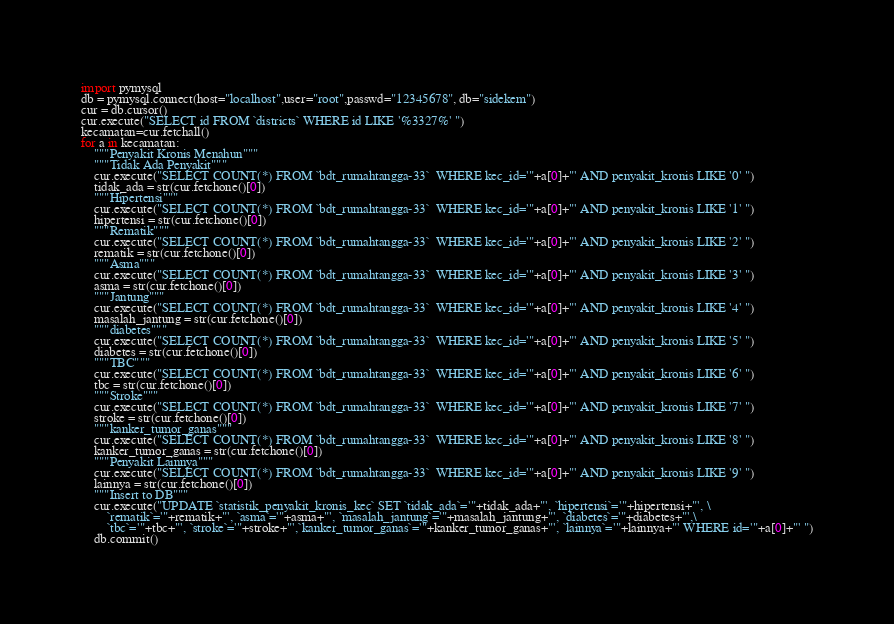<code> <loc_0><loc_0><loc_500><loc_500><_Python_>import pymysql
db = pymysql.connect(host="localhost",user="root",passwd="12345678", db="sidekem")
cur = db.cursor()
cur.execute("SELECT id FROM `districts` WHERE id LIKE '%3327%' ")
kecamatan=cur.fetchall()
for a in kecamatan:
    """Penyakit Kronis Menahun"""
    """Tidak Ada Penyakit"""
    cur.execute("SELECT COUNT(*) FROM `bdt_rumahtangga-33`  WHERE kec_id='"+a[0]+"' AND penyakit_kronis LIKE '0' ")
    tidak_ada = str(cur.fetchone()[0])
    """Hipertensi"""
    cur.execute("SELECT COUNT(*) FROM `bdt_rumahtangga-33`  WHERE kec_id='"+a[0]+"' AND penyakit_kronis LIKE '1' ")
    hipertensi = str(cur.fetchone()[0])
    """Rematik"""
    cur.execute("SELECT COUNT(*) FROM `bdt_rumahtangga-33`  WHERE kec_id='"+a[0]+"' AND penyakit_kronis LIKE '2' ")
    rematik = str(cur.fetchone()[0])
    """Asma"""
    cur.execute("SELECT COUNT(*) FROM `bdt_rumahtangga-33`  WHERE kec_id='"+a[0]+"' AND penyakit_kronis LIKE '3' ")
    asma = str(cur.fetchone()[0])
    """Jantung"""
    cur.execute("SELECT COUNT(*) FROM `bdt_rumahtangga-33`  WHERE kec_id='"+a[0]+"' AND penyakit_kronis LIKE '4' ")
    masalah_jantung = str(cur.fetchone()[0])
    """diabetes"""
    cur.execute("SELECT COUNT(*) FROM `bdt_rumahtangga-33`  WHERE kec_id='"+a[0]+"' AND penyakit_kronis LIKE '5' ")
    diabetes = str(cur.fetchone()[0])
    """TBC"""
    cur.execute("SELECT COUNT(*) FROM `bdt_rumahtangga-33`  WHERE kec_id='"+a[0]+"' AND penyakit_kronis LIKE '6' ")
    tbc = str(cur.fetchone()[0])
    """Stroke"""
    cur.execute("SELECT COUNT(*) FROM `bdt_rumahtangga-33`  WHERE kec_id='"+a[0]+"' AND penyakit_kronis LIKE '7' ")
    stroke = str(cur.fetchone()[0])
    """kanker_tumor_ganas"""
    cur.execute("SELECT COUNT(*) FROM `bdt_rumahtangga-33`  WHERE kec_id='"+a[0]+"' AND penyakit_kronis LIKE '8' ")
    kanker_tumor_ganas = str(cur.fetchone()[0])
    """Penyakit Lainnya"""
    cur.execute("SELECT COUNT(*) FROM `bdt_rumahtangga-33`  WHERE kec_id='"+a[0]+"' AND penyakit_kronis LIKE '9' ")
    lainnya = str(cur.fetchone()[0])
    """Insert to DB"""
    cur.execute("UPDATE `statistik_penyakit_kronis_kec` SET `tidak_ada`='"+tidak_ada+"', `hipertensi`='"+hipertensi+"', \
        `rematik`='"+rematik+"', `asma`='"+asma+"', `masalah_jantung`='"+masalah_jantung+"', `diabetes`='"+diabetes+"',\
        `tbc`='"+tbc+"', `stroke`='"+stroke+"',`kanker_tumor_ganas`='"+kanker_tumor_ganas+"', `lainnya`='"+lainnya+"' WHERE id='"+a[0]+"' ")
    db.commit()
</code> 